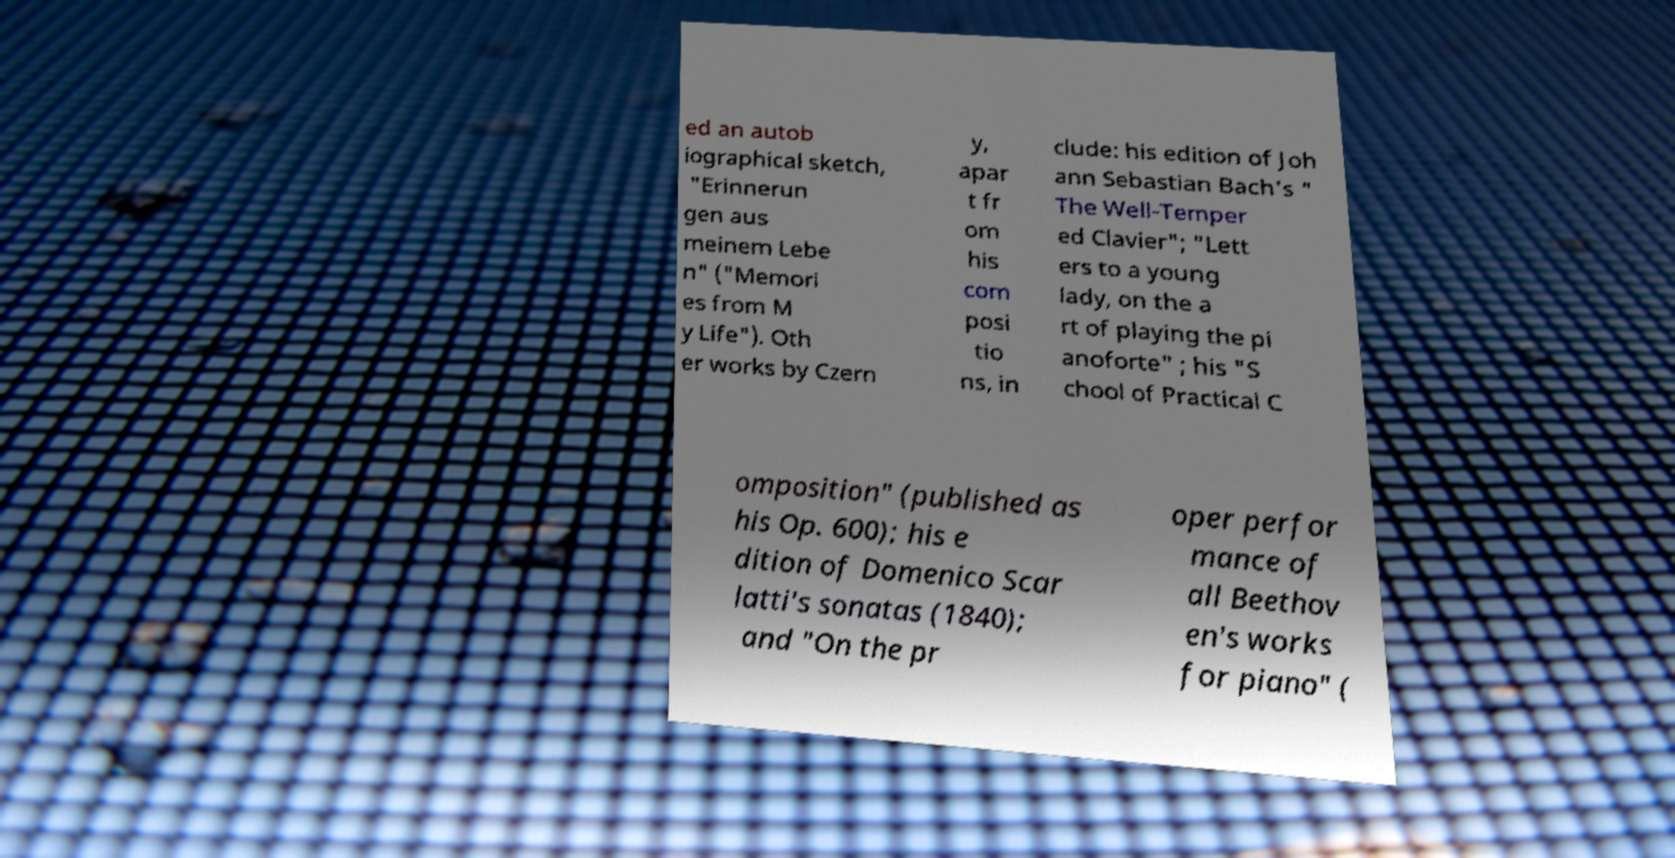I need the written content from this picture converted into text. Can you do that? ed an autob iographical sketch, "Erinnerun gen aus meinem Lebe n" ("Memori es from M y Life"). Oth er works by Czern y, apar t fr om his com posi tio ns, in clude: his edition of Joh ann Sebastian Bach's " The Well-Temper ed Clavier"; "Lett ers to a young lady, on the a rt of playing the pi anoforte" ; his "S chool of Practical C omposition" (published as his Op. 600); his e dition of Domenico Scar latti's sonatas (1840); and "On the pr oper perfor mance of all Beethov en's works for piano" ( 